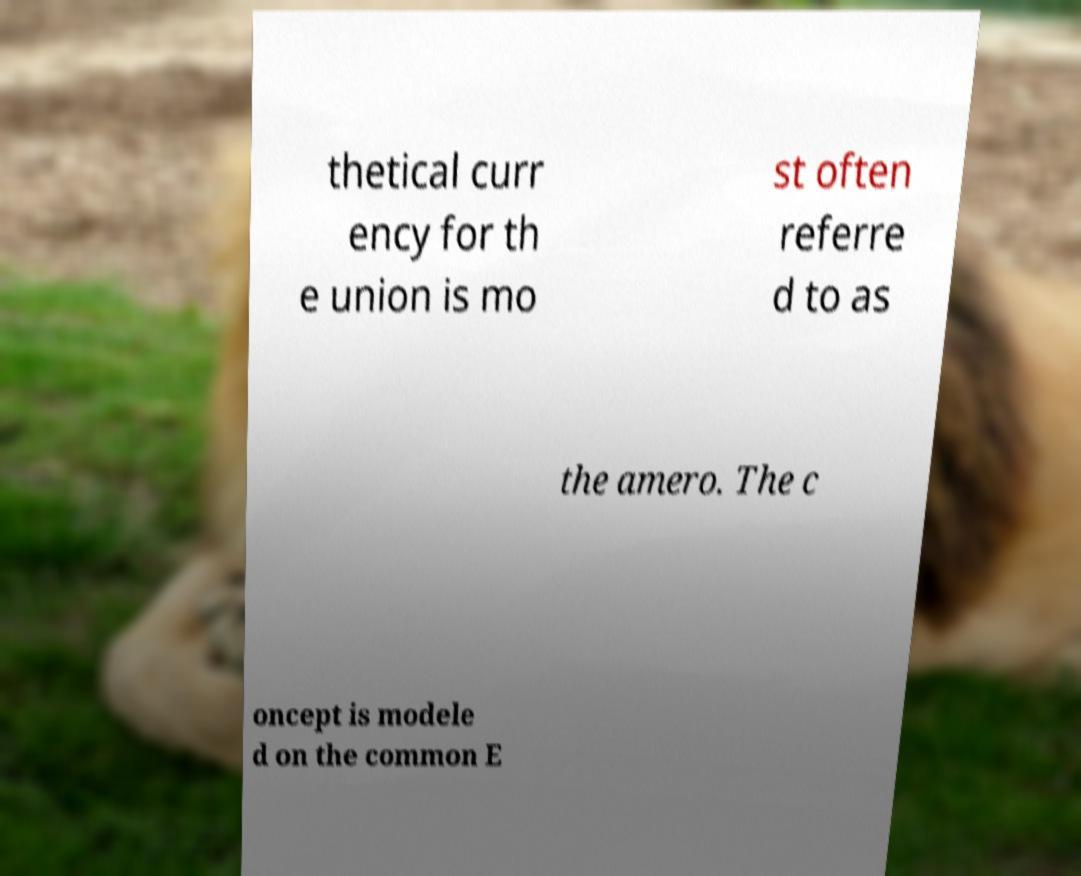Can you accurately transcribe the text from the provided image for me? thetical curr ency for th e union is mo st often referre d to as the amero. The c oncept is modele d on the common E 